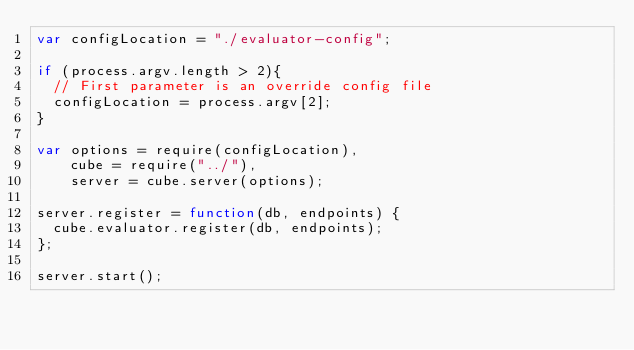<code> <loc_0><loc_0><loc_500><loc_500><_JavaScript_>var configLocation = "./evaluator-config";

if (process.argv.length > 2){
  // First parameter is an override config file
  configLocation = process.argv[2];
}

var options = require(configLocation),
    cube = require("../"),
    server = cube.server(options);

server.register = function(db, endpoints) {
  cube.evaluator.register(db, endpoints);
};

server.start();
</code> 